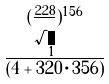<formula> <loc_0><loc_0><loc_500><loc_500>\frac { ( \frac { 2 2 8 } { \sqrt { 1 } } ) ^ { 1 5 6 } } { ( 4 + 3 2 0 \cdot 3 5 6 ) }</formula> 